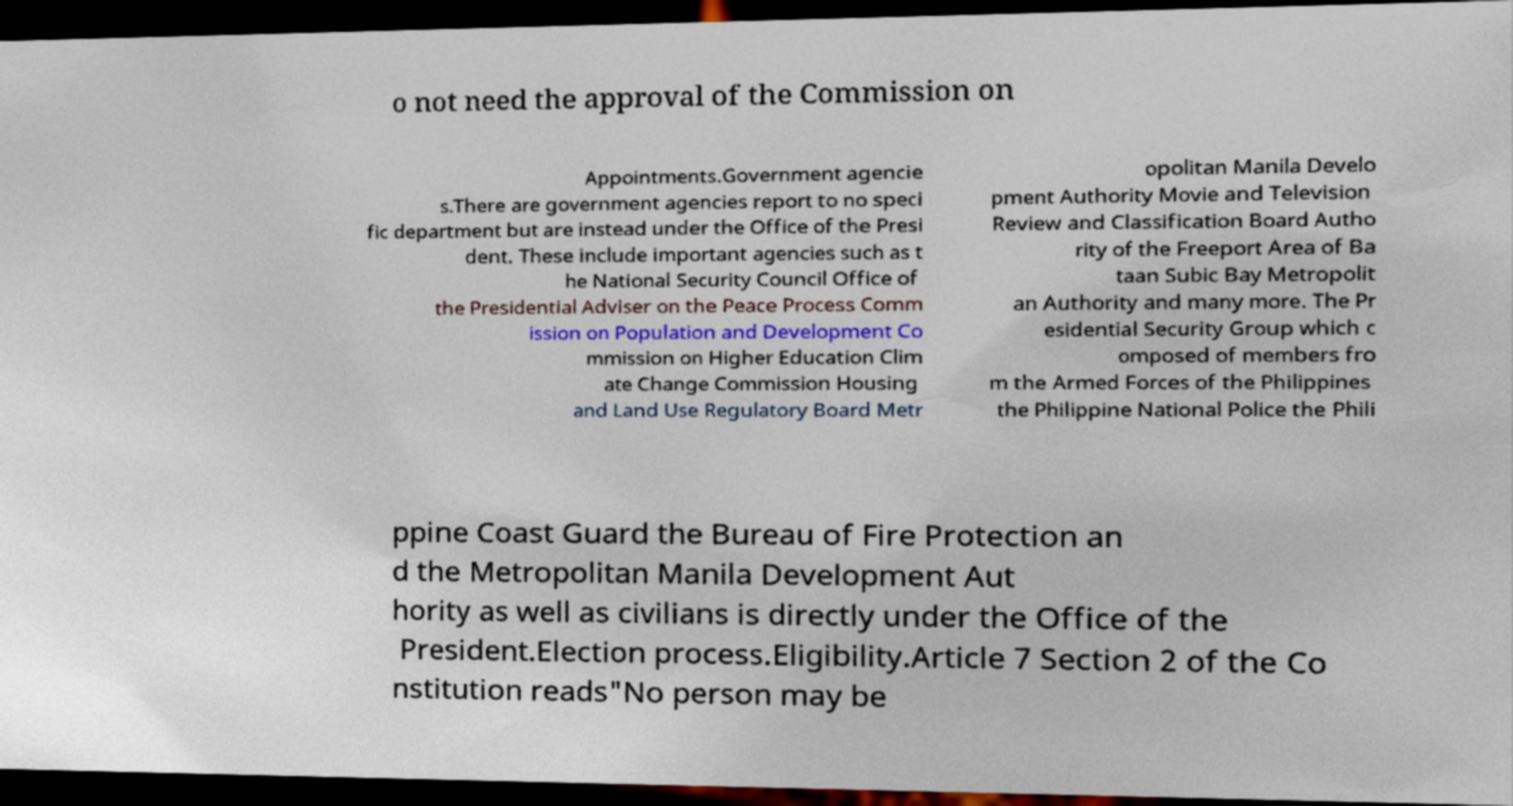For documentation purposes, I need the text within this image transcribed. Could you provide that? o not need the approval of the Commission on Appointments.Government agencie s.There are government agencies report to no speci fic department but are instead under the Office of the Presi dent. These include important agencies such as t he National Security Council Office of the Presidential Adviser on the Peace Process Comm ission on Population and Development Co mmission on Higher Education Clim ate Change Commission Housing and Land Use Regulatory Board Metr opolitan Manila Develo pment Authority Movie and Television Review and Classification Board Autho rity of the Freeport Area of Ba taan Subic Bay Metropolit an Authority and many more. The Pr esidential Security Group which c omposed of members fro m the Armed Forces of the Philippines the Philippine National Police the Phili ppine Coast Guard the Bureau of Fire Protection an d the Metropolitan Manila Development Aut hority as well as civilians is directly under the Office of the President.Election process.Eligibility.Article 7 Section 2 of the Co nstitution reads"No person may be 